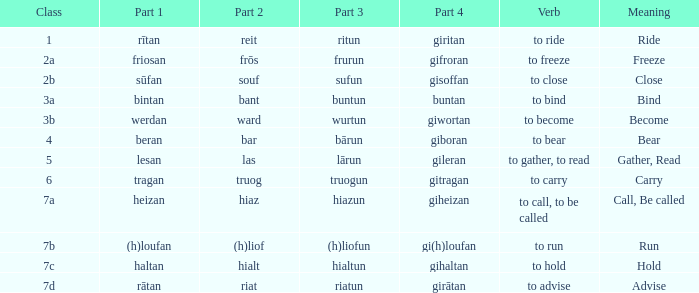What is the verb meaning of the word with part 2 "bant"? To bind. 